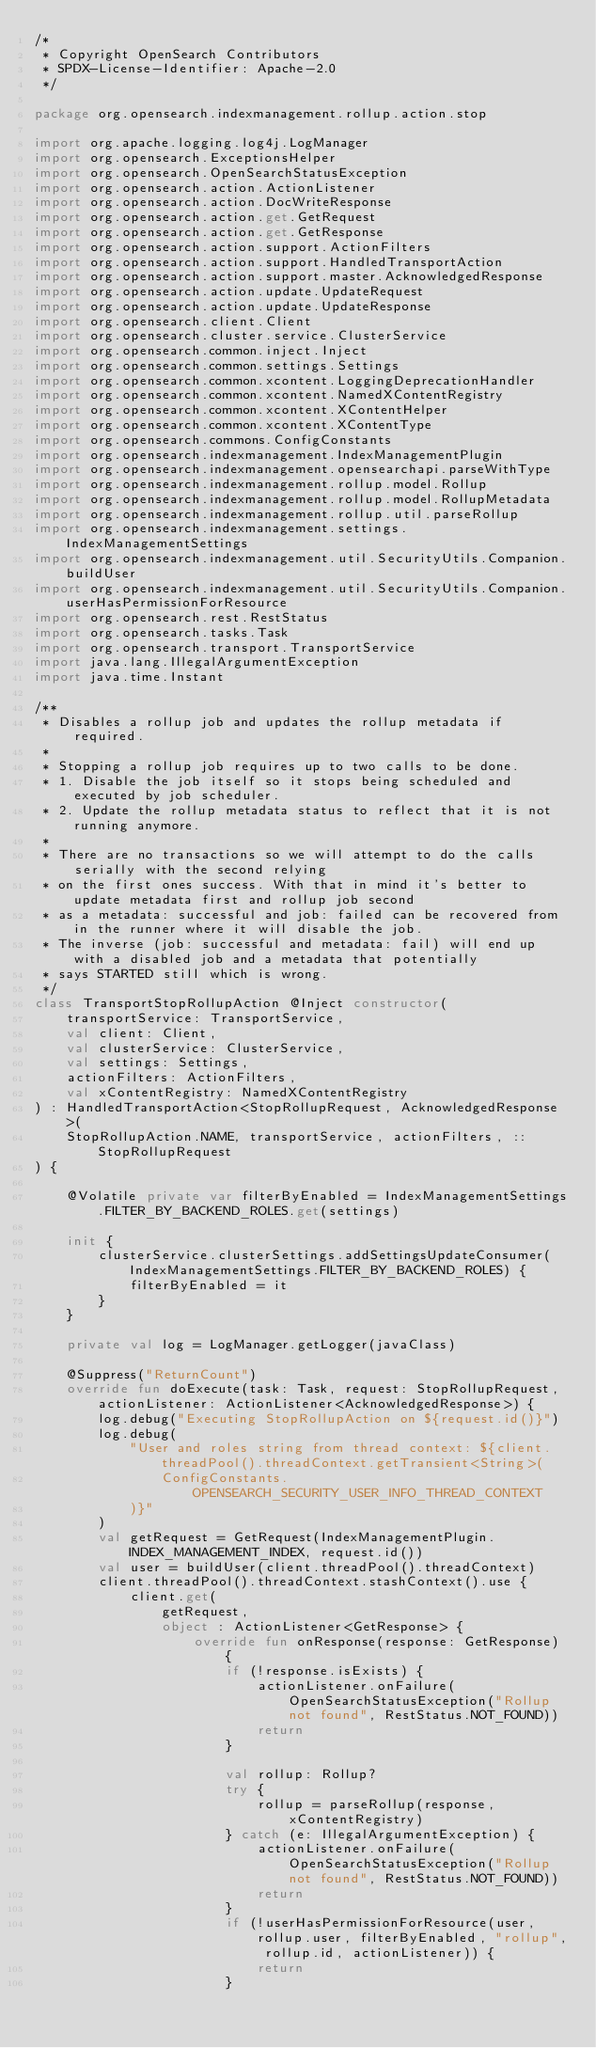Convert code to text. <code><loc_0><loc_0><loc_500><loc_500><_Kotlin_>/*
 * Copyright OpenSearch Contributors
 * SPDX-License-Identifier: Apache-2.0
 */

package org.opensearch.indexmanagement.rollup.action.stop

import org.apache.logging.log4j.LogManager
import org.opensearch.ExceptionsHelper
import org.opensearch.OpenSearchStatusException
import org.opensearch.action.ActionListener
import org.opensearch.action.DocWriteResponse
import org.opensearch.action.get.GetRequest
import org.opensearch.action.get.GetResponse
import org.opensearch.action.support.ActionFilters
import org.opensearch.action.support.HandledTransportAction
import org.opensearch.action.support.master.AcknowledgedResponse
import org.opensearch.action.update.UpdateRequest
import org.opensearch.action.update.UpdateResponse
import org.opensearch.client.Client
import org.opensearch.cluster.service.ClusterService
import org.opensearch.common.inject.Inject
import org.opensearch.common.settings.Settings
import org.opensearch.common.xcontent.LoggingDeprecationHandler
import org.opensearch.common.xcontent.NamedXContentRegistry
import org.opensearch.common.xcontent.XContentHelper
import org.opensearch.common.xcontent.XContentType
import org.opensearch.commons.ConfigConstants
import org.opensearch.indexmanagement.IndexManagementPlugin
import org.opensearch.indexmanagement.opensearchapi.parseWithType
import org.opensearch.indexmanagement.rollup.model.Rollup
import org.opensearch.indexmanagement.rollup.model.RollupMetadata
import org.opensearch.indexmanagement.rollup.util.parseRollup
import org.opensearch.indexmanagement.settings.IndexManagementSettings
import org.opensearch.indexmanagement.util.SecurityUtils.Companion.buildUser
import org.opensearch.indexmanagement.util.SecurityUtils.Companion.userHasPermissionForResource
import org.opensearch.rest.RestStatus
import org.opensearch.tasks.Task
import org.opensearch.transport.TransportService
import java.lang.IllegalArgumentException
import java.time.Instant

/**
 * Disables a rollup job and updates the rollup metadata if required.
 *
 * Stopping a rollup job requires up to two calls to be done.
 * 1. Disable the job itself so it stops being scheduled and executed by job scheduler.
 * 2. Update the rollup metadata status to reflect that it is not running anymore.
 *
 * There are no transactions so we will attempt to do the calls serially with the second relying
 * on the first ones success. With that in mind it's better to update metadata first and rollup job second
 * as a metadata: successful and job: failed can be recovered from in the runner where it will disable the job.
 * The inverse (job: successful and metadata: fail) will end up with a disabled job and a metadata that potentially
 * says STARTED still which is wrong.
 */
class TransportStopRollupAction @Inject constructor(
    transportService: TransportService,
    val client: Client,
    val clusterService: ClusterService,
    val settings: Settings,
    actionFilters: ActionFilters,
    val xContentRegistry: NamedXContentRegistry
) : HandledTransportAction<StopRollupRequest, AcknowledgedResponse>(
    StopRollupAction.NAME, transportService, actionFilters, ::StopRollupRequest
) {

    @Volatile private var filterByEnabled = IndexManagementSettings.FILTER_BY_BACKEND_ROLES.get(settings)

    init {
        clusterService.clusterSettings.addSettingsUpdateConsumer(IndexManagementSettings.FILTER_BY_BACKEND_ROLES) {
            filterByEnabled = it
        }
    }

    private val log = LogManager.getLogger(javaClass)

    @Suppress("ReturnCount")
    override fun doExecute(task: Task, request: StopRollupRequest, actionListener: ActionListener<AcknowledgedResponse>) {
        log.debug("Executing StopRollupAction on ${request.id()}")
        log.debug(
            "User and roles string from thread context: ${client.threadPool().threadContext.getTransient<String>(
                ConfigConstants.OPENSEARCH_SECURITY_USER_INFO_THREAD_CONTEXT
            )}"
        )
        val getRequest = GetRequest(IndexManagementPlugin.INDEX_MANAGEMENT_INDEX, request.id())
        val user = buildUser(client.threadPool().threadContext)
        client.threadPool().threadContext.stashContext().use {
            client.get(
                getRequest,
                object : ActionListener<GetResponse> {
                    override fun onResponse(response: GetResponse) {
                        if (!response.isExists) {
                            actionListener.onFailure(OpenSearchStatusException("Rollup not found", RestStatus.NOT_FOUND))
                            return
                        }

                        val rollup: Rollup?
                        try {
                            rollup = parseRollup(response, xContentRegistry)
                        } catch (e: IllegalArgumentException) {
                            actionListener.onFailure(OpenSearchStatusException("Rollup not found", RestStatus.NOT_FOUND))
                            return
                        }
                        if (!userHasPermissionForResource(user, rollup.user, filterByEnabled, "rollup", rollup.id, actionListener)) {
                            return
                        }</code> 